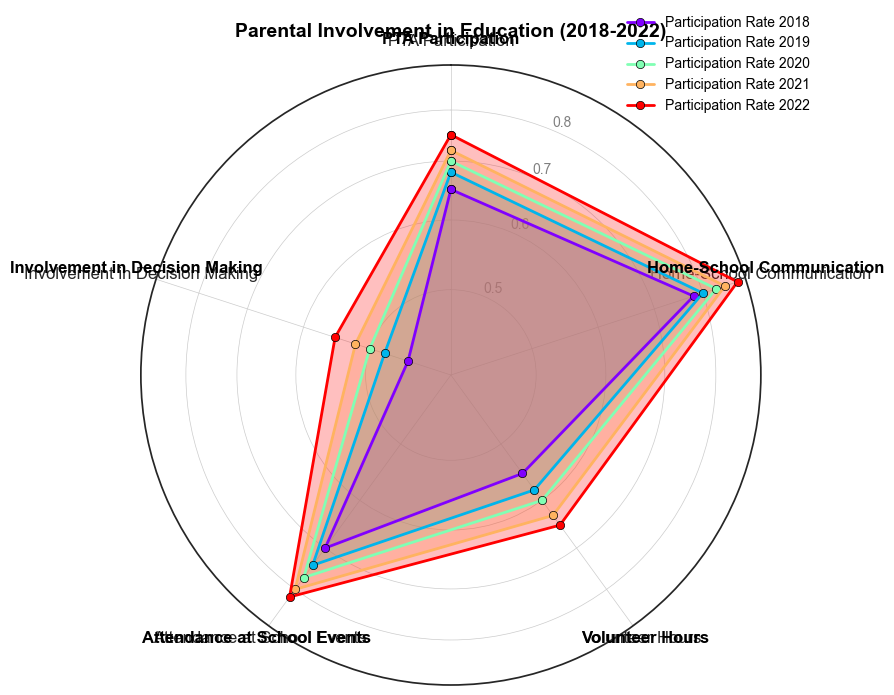What category had the highest participation rate in 2022? Look at the data for 2022 and identify the category with the highest value. Home-School Communication has the value of 0.88 which is the highest among all categories.
Answer: Home-School Communication Which year saw the biggest increase in PTA Participation compared to the previous year? First, calculate the difference in PTA Participation between consecutive years: 2019-2018 = 0.03, 2020-2019 = 0.02, 2021-2020 = 0.02, 2022-2021 = 0.03. The year 2019 and 2022 both saw an increase of 0.03.
Answer: 2019 and 2022 What is the overall trend for Volunteer Hours from 2018 to 2022? Evaluate the values for Volunteer Hours across the years: 0.55, 0.58, 0.60, 0.63, 0.65. The values show a steady increase each year.
Answer: Increasing Which category showed the least involvement in decision making in 2020? Identify the value for Involvement in Decision Making in 2020, which is 0.50. Compare this value with other categories in 2020. It is the lowest value among Home-School Communication (0.83), Volunteer Hours (0.60), Attendance at School Events (0.77), and PTA Participation (0.70).
Answer: Involvement in Decision Making What is the average participation rate for Attendance at School Events over the five years? Sum the values for Attendance at School Events: 0.70 + 0.74 + 0.77 + 0.80 + 0.82 = 3.83. Divide this sum by 5 to find the average: 3.83 / 5 = 0.766.
Answer: 0.766 How did Home-School Communication participation change from 2018 to 2022? Compare the participation rates for Home-School Communication in 2018 and 2022. The participation rate went from 0.78 in 2018 to 0.88 in 2022, showing an increase.
Answer: Increased Which year had the smallest participation rate for Involvement in Decision Making? Look at the values for Involvement in Decision Making for all years: 2018 (0.45), 2019 (0.48), 2020 (0.50), 2021 (0.52), 2022 (0.55). The smallest participation rate was in 2018 with 0.45.
Answer: 2018 Which category showed the smallest range of participation rates over the five years? Calculate the range (maximum minus minimum) for each category: 
PTA Participation = 0.75 - 0.65 = 0.10,
Home-School Communication = 0.88 - 0.78 = 0.10,
Volunteer Hours = 0.65 - 0.55 = 0.10,
Attendance at School Events = 0.82 - 0.70 = 0.12,
Involvement in Decision Making = 0.55 - 0.45 = 0.10. 
Three categories (PTA Participation, Home-School Communication, and Volunteer Hours) showed the smallest range of 0.10.
Answer: PTA Participation, Home-School Communication, Volunteer Hours 